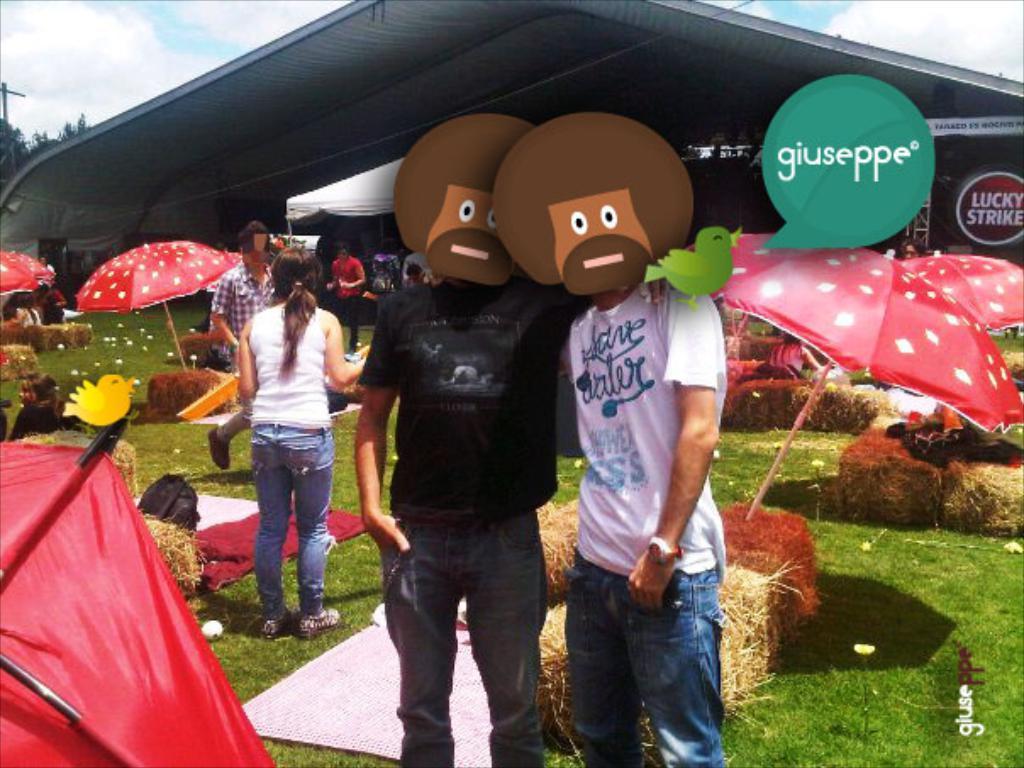How would you summarize this image in a sentence or two? In the center of the image we can see two people are standing and wearing the masks. In the background of the image we can see the umbrellas, ground, dry grass, boards, trees, pole, shed, tent and some people are standing. In the bottom right corner we can see the text. At the top of the image we can see the clouds in the sky. 